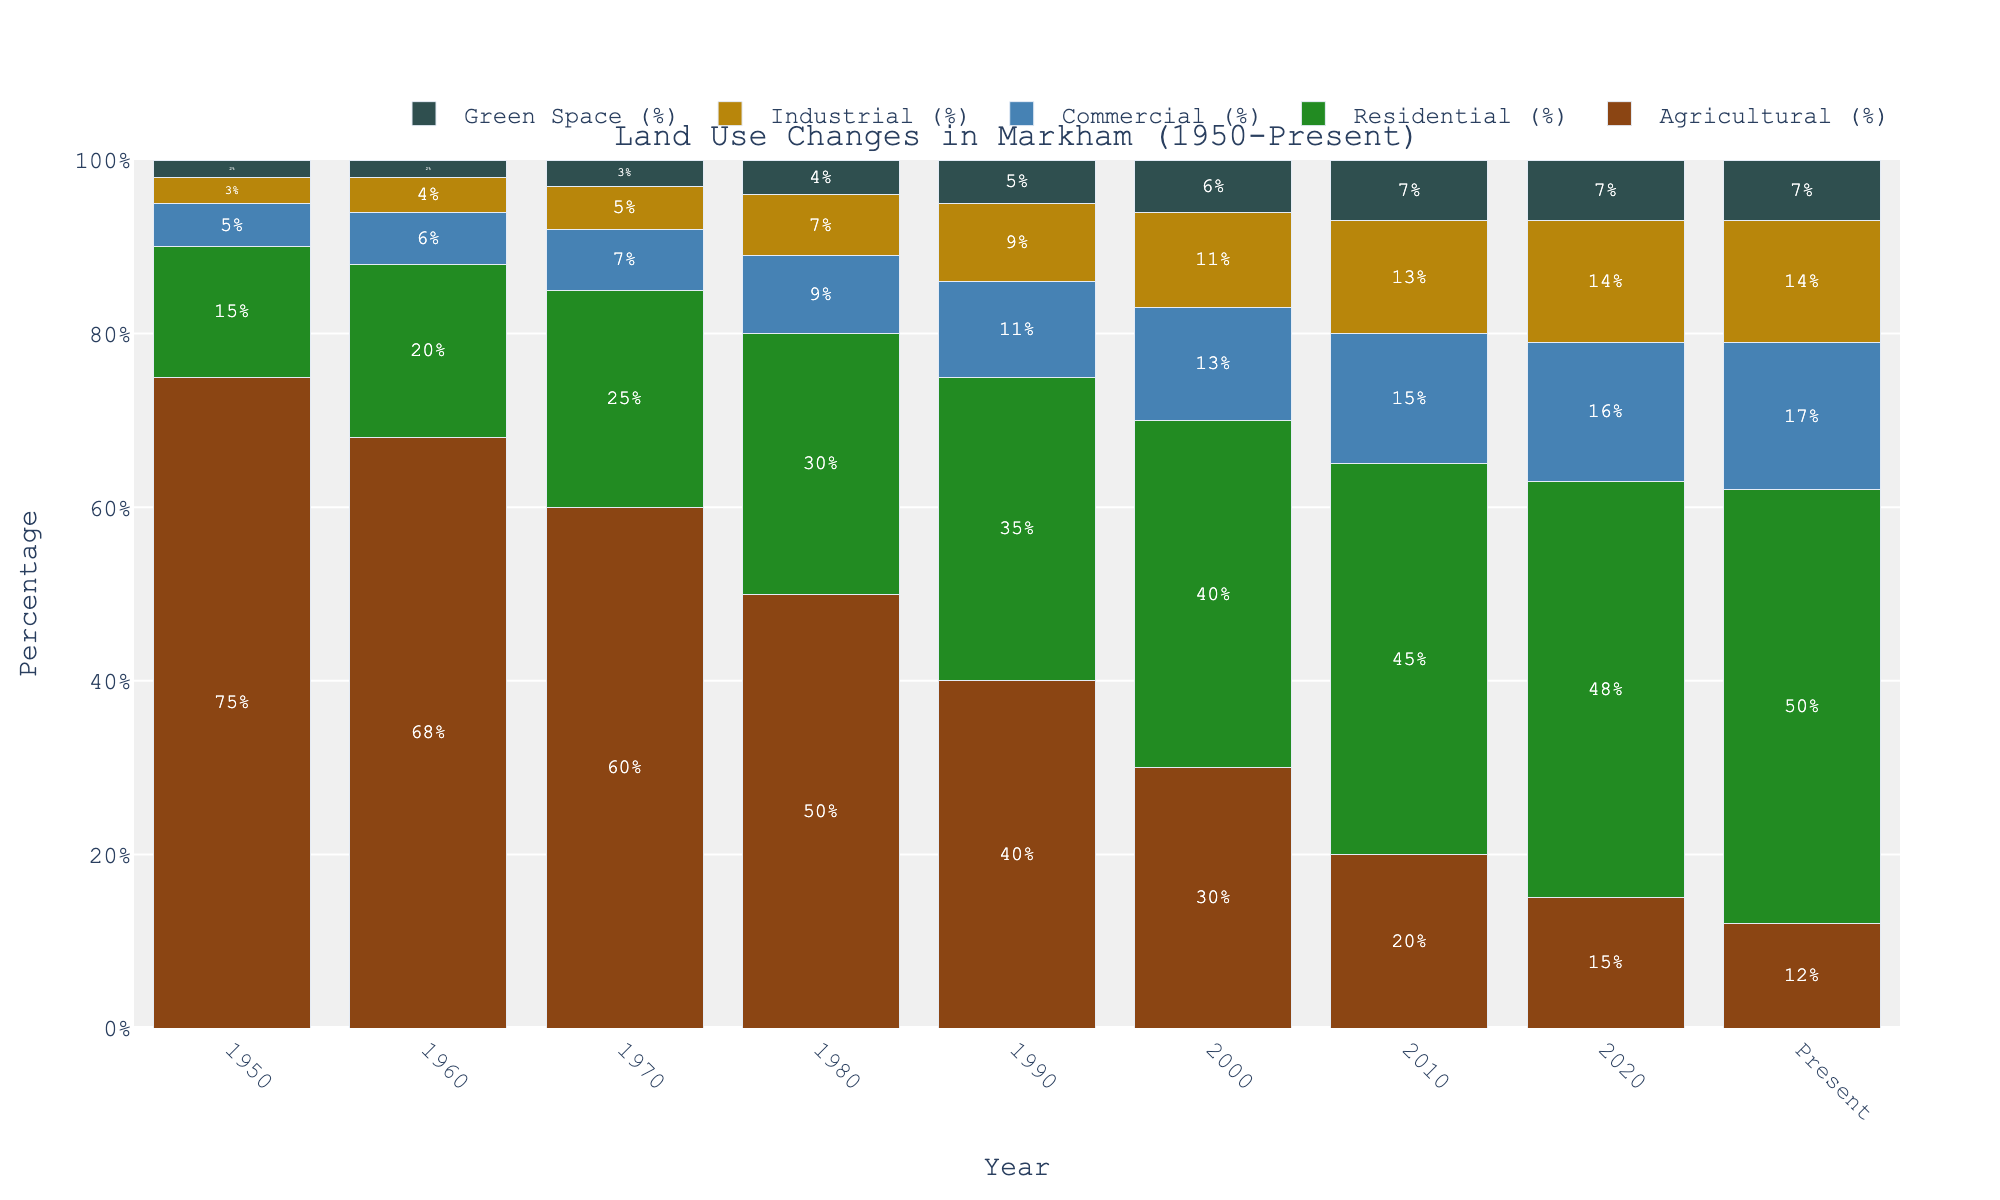What is the percentage decrease in agricultural land use from 1950 to the present? To find this, subtract the present percentage of agricultural land use from the 1950 percentage: 75% (1950) - 12% (present) = 63%.
Answer: 63% Between 1970 and 2020, did residential land use increase or decrease, and by how much? The residential land use in 1970 was 25%, and in 2020 it was 48%. The increase can be calculated as 48% - 25% = 23%.
Answer: Increase by 23% Which year had the highest percentage of green space? Check the percentage of green space for each year and find the highest value. Present, 2020, and 2010 all have the highest value at 7%.
Answer: Present, 2020, and 2010 How did commercial land use change between 1980 and 2000? The commercial land use in 1980 was 9%, and in 2000 it was 13%. The change can be calculated as 13% - 9% = 4%.
Answer: Increased by 4% What land use category had the least percentage change from 1950 to the present? By calculating the differences for each category from 1950 to the present: Agricultural: 75% - 12% = 63%, Residential: 15% - 50% = -35%, Commercial: 5% - 17% = -12%, Industrial: 3% - 14% = -11%, Green Space: 2% - 7% = 5%. The least change is in Green Space (5%).
Answer: Green Space In which year did residential land use first surpass agricultural land use? By comparing the percentages year by year, residential land use first exceeds agricultural land use in 1990 (Residential: 35%, Agricultural: 40%).
Answer: 1990 What is the combined percentage of industrial and commercial land use in the present year? Add the industrial and commercial land use percentages for the present year: 17% (Commercial) + 14% (Industrial) = 31%.
Answer: 31% 